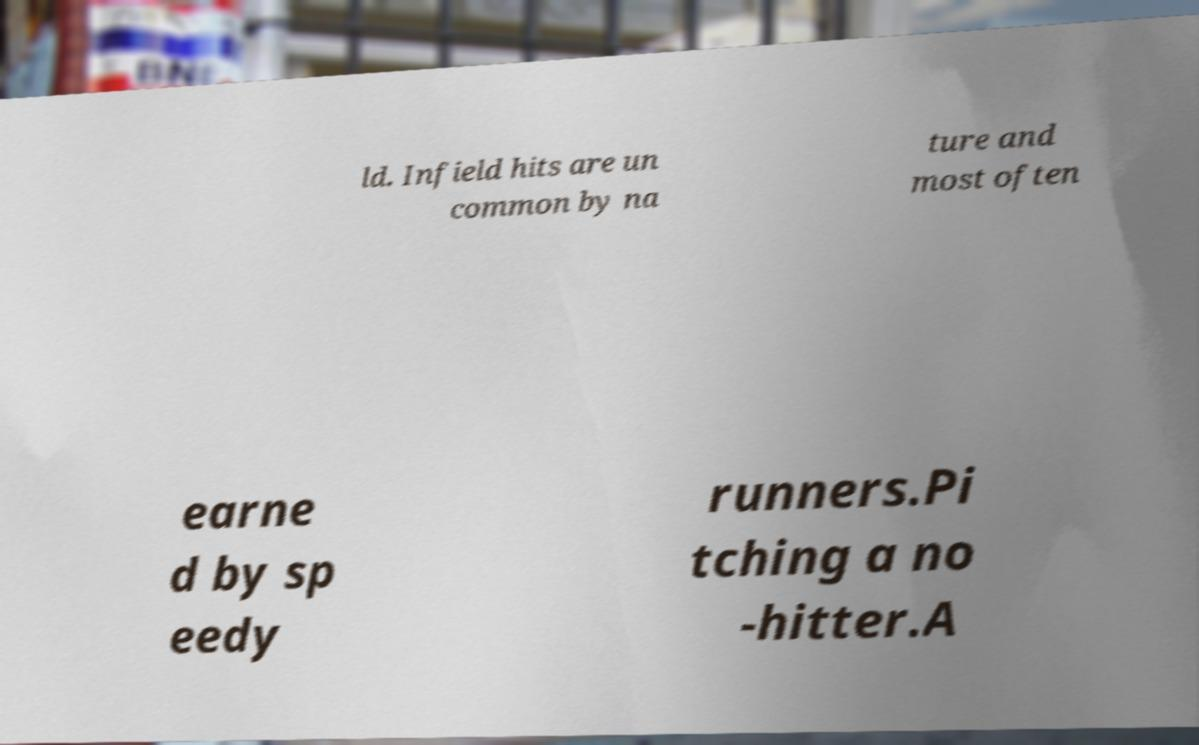Can you read and provide the text displayed in the image?This photo seems to have some interesting text. Can you extract and type it out for me? ld. Infield hits are un common by na ture and most often earne d by sp eedy runners.Pi tching a no -hitter.A 